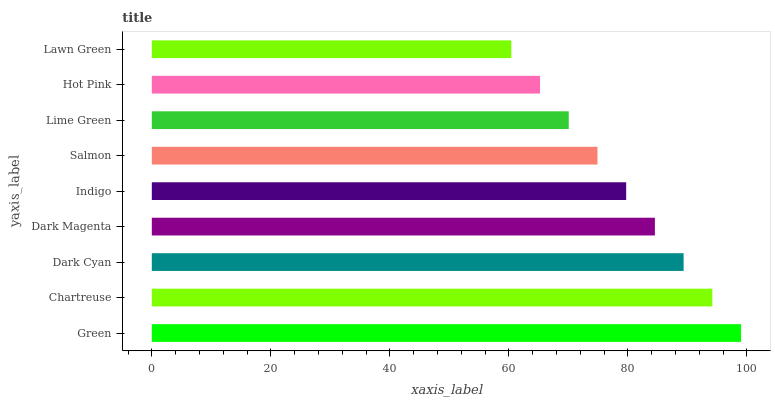Is Lawn Green the minimum?
Answer yes or no. Yes. Is Green the maximum?
Answer yes or no. Yes. Is Chartreuse the minimum?
Answer yes or no. No. Is Chartreuse the maximum?
Answer yes or no. No. Is Green greater than Chartreuse?
Answer yes or no. Yes. Is Chartreuse less than Green?
Answer yes or no. Yes. Is Chartreuse greater than Green?
Answer yes or no. No. Is Green less than Chartreuse?
Answer yes or no. No. Is Indigo the high median?
Answer yes or no. Yes. Is Indigo the low median?
Answer yes or no. Yes. Is Dark Cyan the high median?
Answer yes or no. No. Is Dark Cyan the low median?
Answer yes or no. No. 